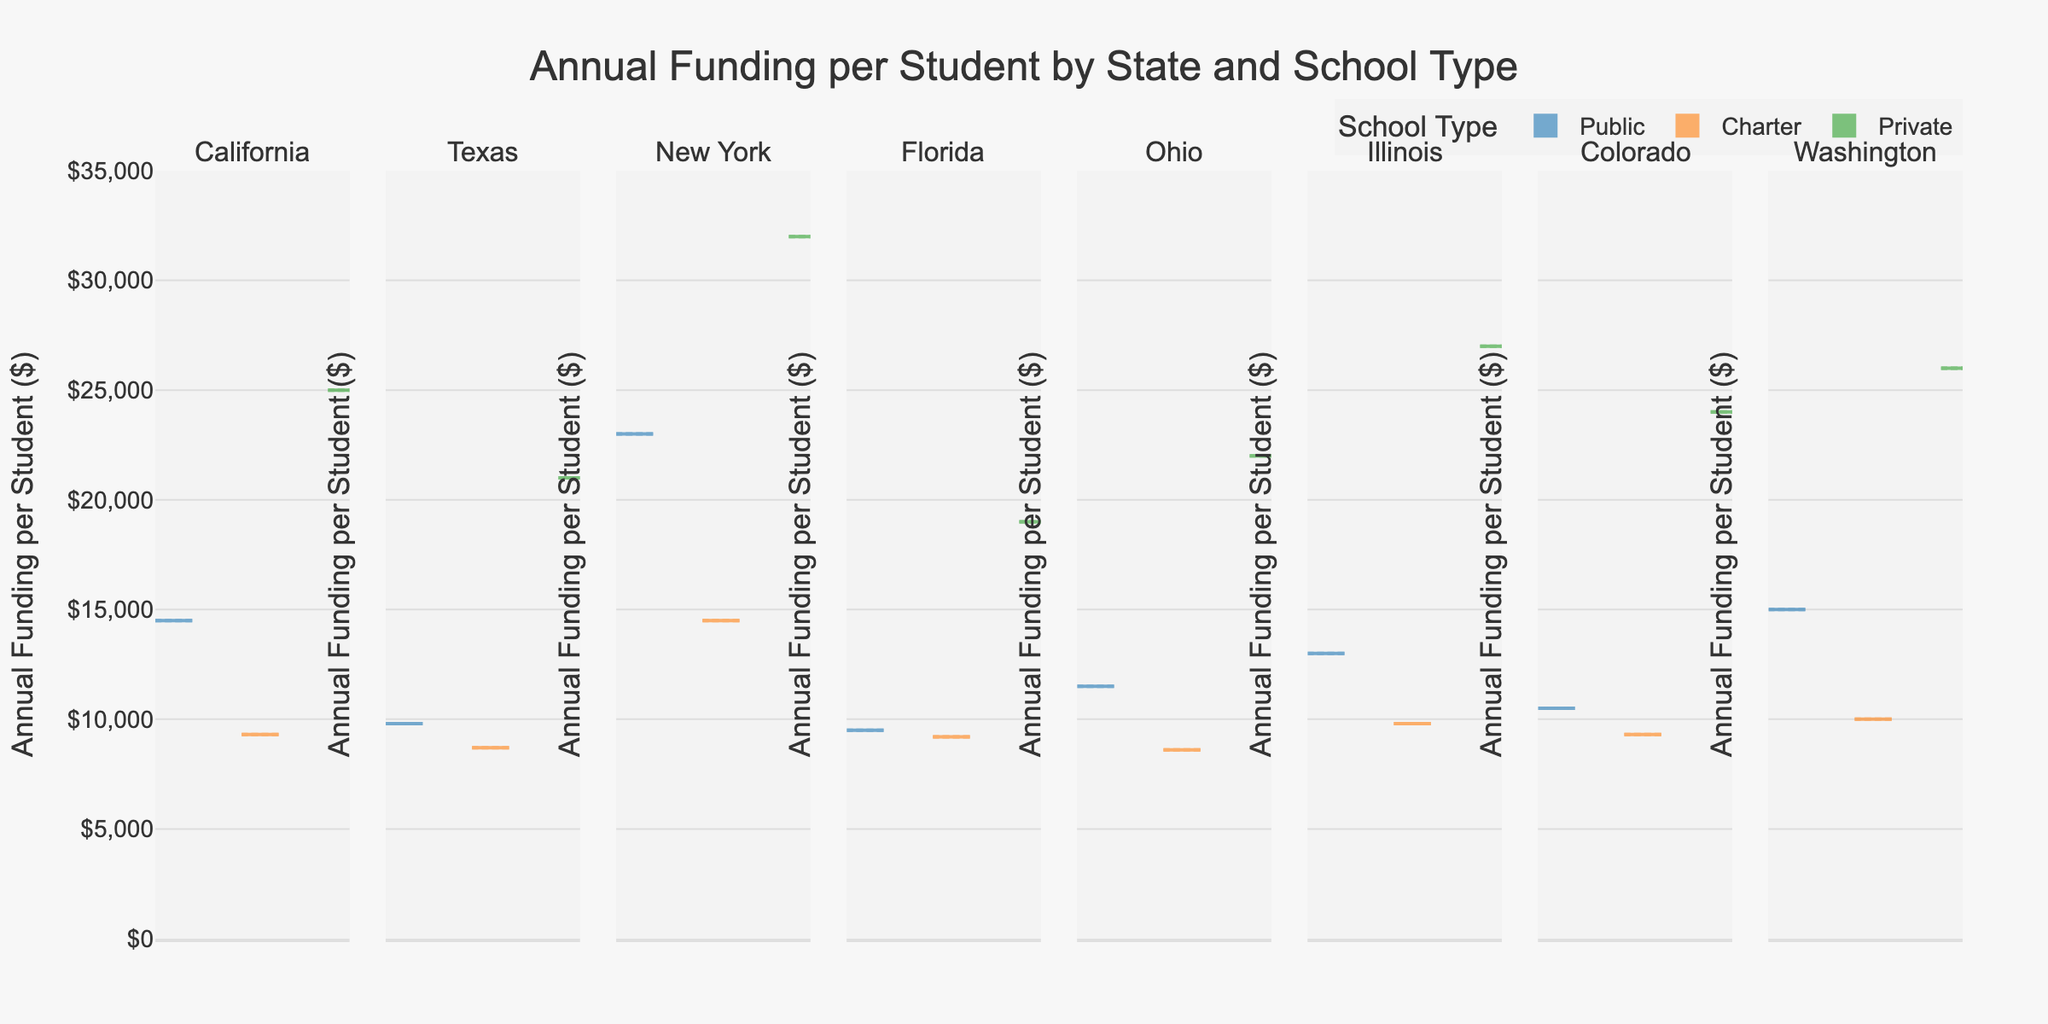Which state has the highest annual funding for public schools? Look at the violin plots for public schools and identify the state with the highest peak.
Answer: New York What is the range of annual funding per student in private schools in Florida? Identify the violin plot for private schools in Florida and observe the range from the lowest to the highest point.
Answer: $19,000 Which school type in Texas has the lowest annual funding per student? Observe the violin plots for Texas and compare the peak positions for public, charter, and private schools.
Answer: Charter How does the funding variance for charter schools in California compare to private schools in Illinois? Compare the width and dispersion of the violin plots for charter schools in California and private schools in Illinois.
Answer: Charter schools in California have less variance than private schools in Illinois Is there a school type where Washington's funding exceeds Illinois's highest funding? Compare the funding for all school types in Washington with the highest funding value in Illinois.
Answer: Yes, private schools in Washington Which state shows a higher average funding between public and charter schools? Compare the mean lines visible on the violin plots for public and charter schools across states.
Answer: New York For public schools, which state has the most consistent annual funding per student? Identify the violin plot for public schools with the narrowest dispersion, indicating consistency.
Answer: Florida What is the annual funding per student difference between public and private schools in Texas? Observe the peaks for public and private schools in Texas and calculate the difference.
Answer: $11,200 How does the funding for charter schools in Colorado compare to charter schools in Florida? Compare the peak positions of the violin plots for charter schools in Colorado and Florida.
Answer: Higher in Florida In terms of educational funding, which school type has the highest disparity within a single state? Observe the width and dispersion (shape) of violin plots for all school types and identify which has the widest range within any state.
Answer: Private schools in New York 